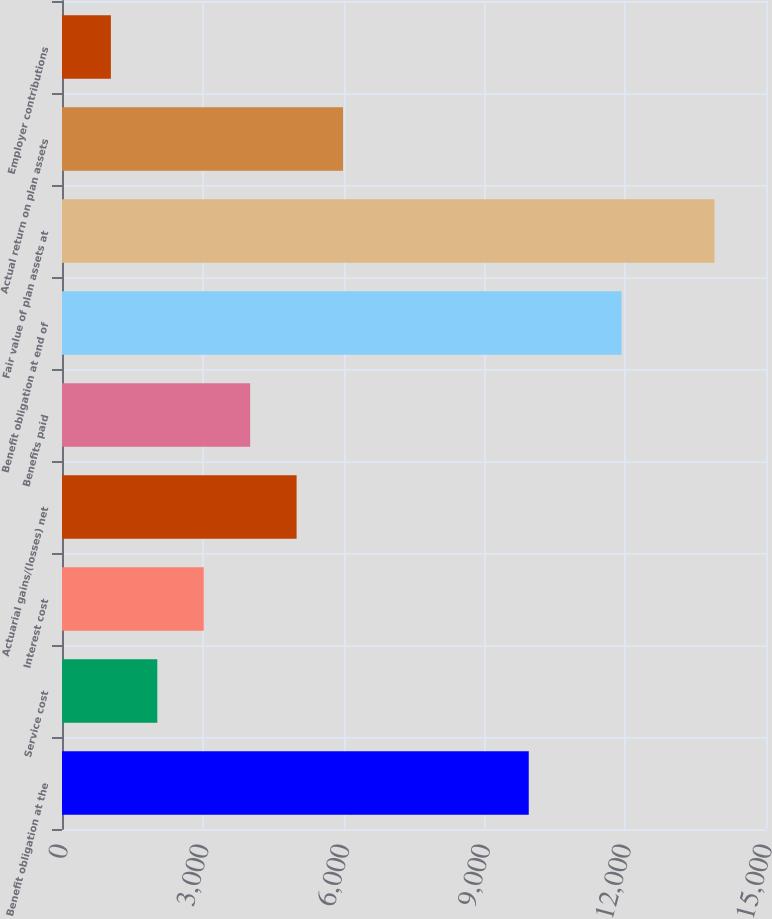Convert chart. <chart><loc_0><loc_0><loc_500><loc_500><bar_chart><fcel>Benefit obligation at the<fcel>Service cost<fcel>Interest cost<fcel>Actuarial gains/(losses) net<fcel>Benefits paid<fcel>Benefit obligation at end of<fcel>Fair value of plan assets at<fcel>Actual return on plan assets<fcel>Employer contributions<nl><fcel>9945<fcel>2030.6<fcel>3019.9<fcel>4998.5<fcel>4009.2<fcel>11923.6<fcel>13902.2<fcel>5987.8<fcel>1041.3<nl></chart> 